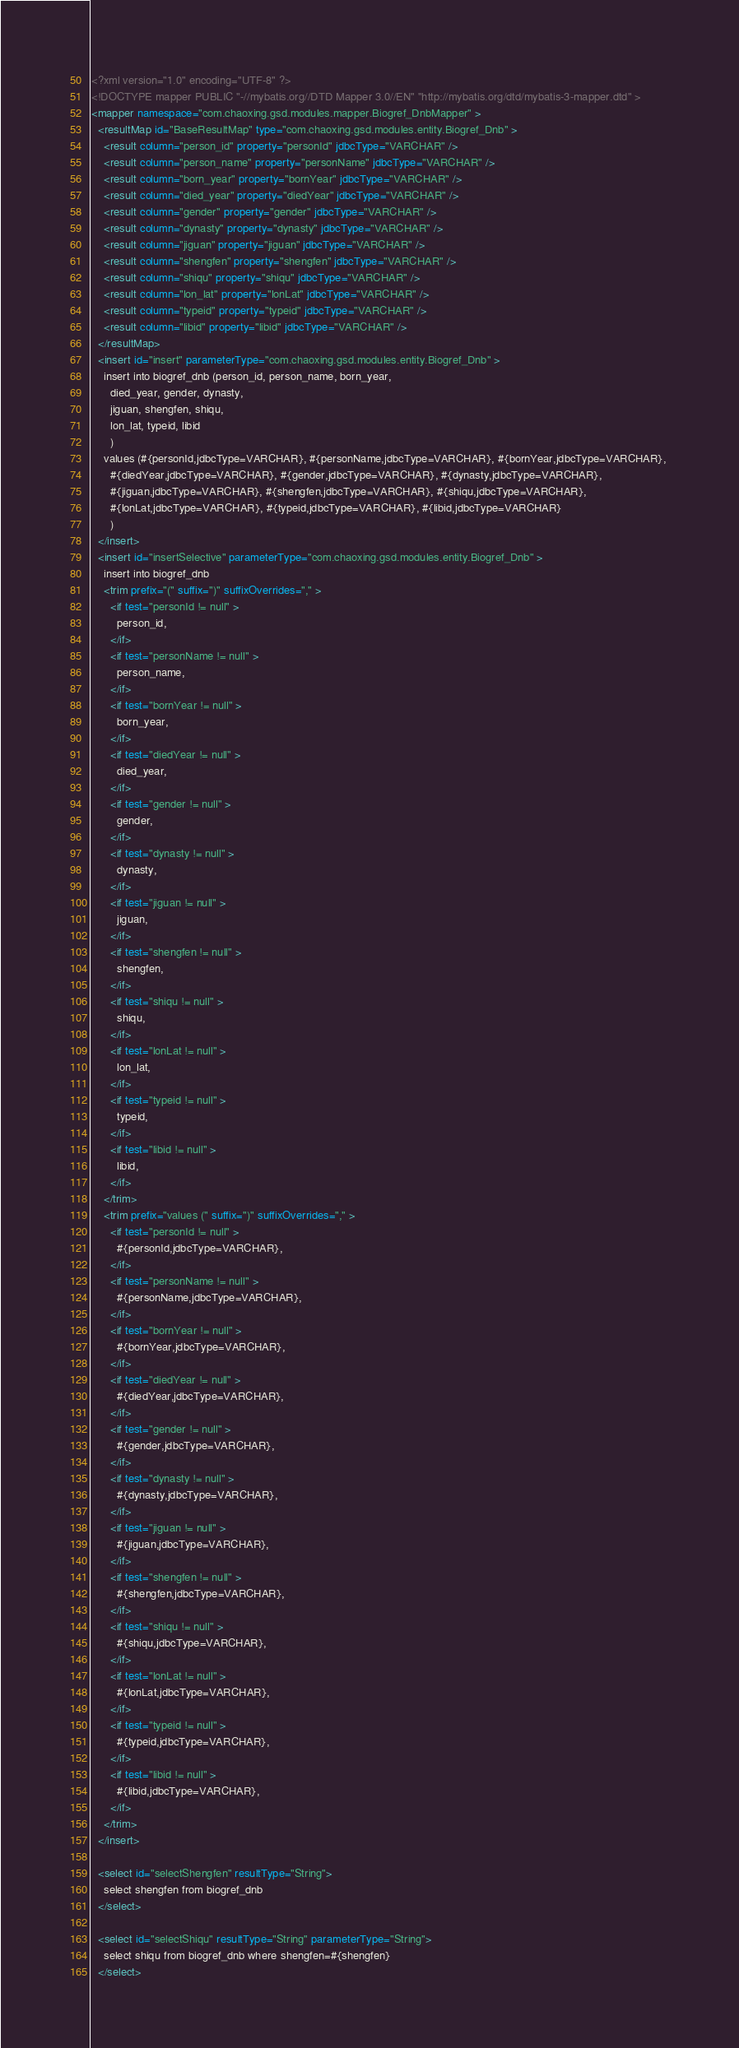<code> <loc_0><loc_0><loc_500><loc_500><_XML_><?xml version="1.0" encoding="UTF-8" ?>
<!DOCTYPE mapper PUBLIC "-//mybatis.org//DTD Mapper 3.0//EN" "http://mybatis.org/dtd/mybatis-3-mapper.dtd" >
<mapper namespace="com.chaoxing.gsd.modules.mapper.Biogref_DnbMapper" >
  <resultMap id="BaseResultMap" type="com.chaoxing.gsd.modules.entity.Biogref_Dnb" >
    <result column="person_id" property="personId" jdbcType="VARCHAR" />
    <result column="person_name" property="personName" jdbcType="VARCHAR" />
    <result column="born_year" property="bornYear" jdbcType="VARCHAR" />
    <result column="died_year" property="diedYear" jdbcType="VARCHAR" />
    <result column="gender" property="gender" jdbcType="VARCHAR" />
    <result column="dynasty" property="dynasty" jdbcType="VARCHAR" />
    <result column="jiguan" property="jiguan" jdbcType="VARCHAR" />
    <result column="shengfen" property="shengfen" jdbcType="VARCHAR" />
    <result column="shiqu" property="shiqu" jdbcType="VARCHAR" />
    <result column="lon_lat" property="lonLat" jdbcType="VARCHAR" />
    <result column="typeid" property="typeid" jdbcType="VARCHAR" />
    <result column="libid" property="libid" jdbcType="VARCHAR" />
  </resultMap>
  <insert id="insert" parameterType="com.chaoxing.gsd.modules.entity.Biogref_Dnb" >
    insert into biogref_dnb (person_id, person_name, born_year, 
      died_year, gender, dynasty, 
      jiguan, shengfen, shiqu, 
      lon_lat, typeid, libid
      )
    values (#{personId,jdbcType=VARCHAR}, #{personName,jdbcType=VARCHAR}, #{bornYear,jdbcType=VARCHAR}, 
      #{diedYear,jdbcType=VARCHAR}, #{gender,jdbcType=VARCHAR}, #{dynasty,jdbcType=VARCHAR}, 
      #{jiguan,jdbcType=VARCHAR}, #{shengfen,jdbcType=VARCHAR}, #{shiqu,jdbcType=VARCHAR}, 
      #{lonLat,jdbcType=VARCHAR}, #{typeid,jdbcType=VARCHAR}, #{libid,jdbcType=VARCHAR}
      )
  </insert>
  <insert id="insertSelective" parameterType="com.chaoxing.gsd.modules.entity.Biogref_Dnb" >
    insert into biogref_dnb
    <trim prefix="(" suffix=")" suffixOverrides="," >
      <if test="personId != null" >
        person_id,
      </if>
      <if test="personName != null" >
        person_name,
      </if>
      <if test="bornYear != null" >
        born_year,
      </if>
      <if test="diedYear != null" >
        died_year,
      </if>
      <if test="gender != null" >
        gender,
      </if>
      <if test="dynasty != null" >
        dynasty,
      </if>
      <if test="jiguan != null" >
        jiguan,
      </if>
      <if test="shengfen != null" >
        shengfen,
      </if>
      <if test="shiqu != null" >
        shiqu,
      </if>
      <if test="lonLat != null" >
        lon_lat,
      </if>
      <if test="typeid != null" >
        typeid,
      </if>
      <if test="libid != null" >
        libid,
      </if>
    </trim>
    <trim prefix="values (" suffix=")" suffixOverrides="," >
      <if test="personId != null" >
        #{personId,jdbcType=VARCHAR},
      </if>
      <if test="personName != null" >
        #{personName,jdbcType=VARCHAR},
      </if>
      <if test="bornYear != null" >
        #{bornYear,jdbcType=VARCHAR},
      </if>
      <if test="diedYear != null" >
        #{diedYear,jdbcType=VARCHAR},
      </if>
      <if test="gender != null" >
        #{gender,jdbcType=VARCHAR},
      </if>
      <if test="dynasty != null" >
        #{dynasty,jdbcType=VARCHAR},
      </if>
      <if test="jiguan != null" >
        #{jiguan,jdbcType=VARCHAR},
      </if>
      <if test="shengfen != null" >
        #{shengfen,jdbcType=VARCHAR},
      </if>
      <if test="shiqu != null" >
        #{shiqu,jdbcType=VARCHAR},
      </if>
      <if test="lonLat != null" >
        #{lonLat,jdbcType=VARCHAR},
      </if>
      <if test="typeid != null" >
        #{typeid,jdbcType=VARCHAR},
      </if>
      <if test="libid != null" >
        #{libid,jdbcType=VARCHAR},
      </if>
    </trim>
  </insert>

  <select id="selectShengfen" resultType="String">
    select shengfen from biogref_dnb
  </select>

  <select id="selectShiqu" resultType="String" parameterType="String">
    select shiqu from biogref_dnb where shengfen=#{shengfen}
  </select>
</code> 